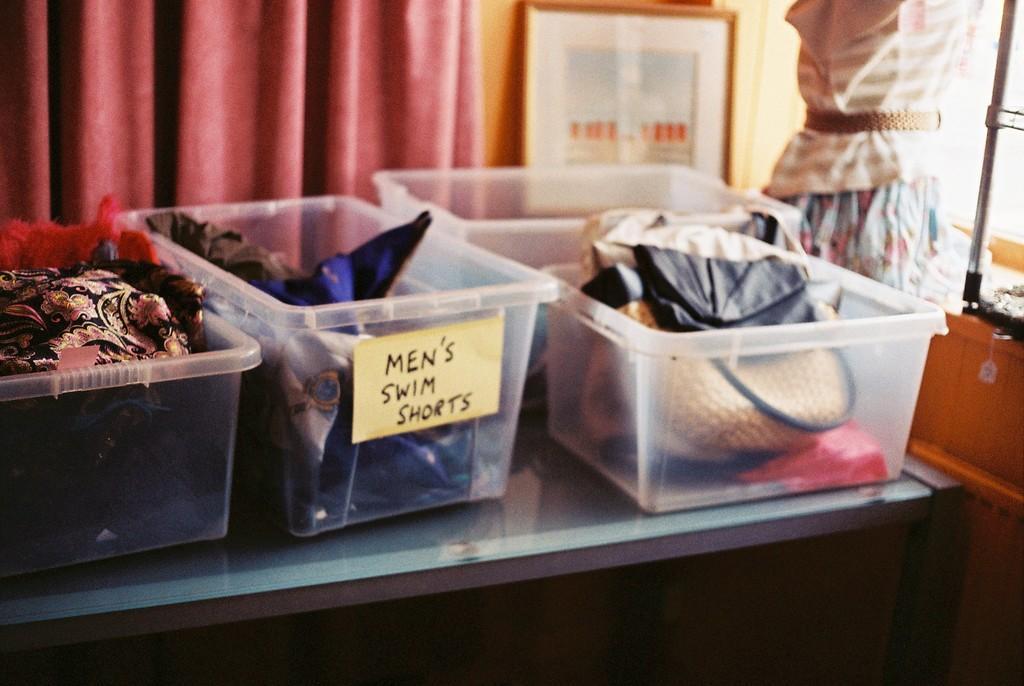Could you give a brief overview of what you see in this image? In this image I can see few objects in the plastic baskets and the baskets are on the table. In the background I can see few curtains in maroon color and I can also see the frame and the wall is in orange color. 